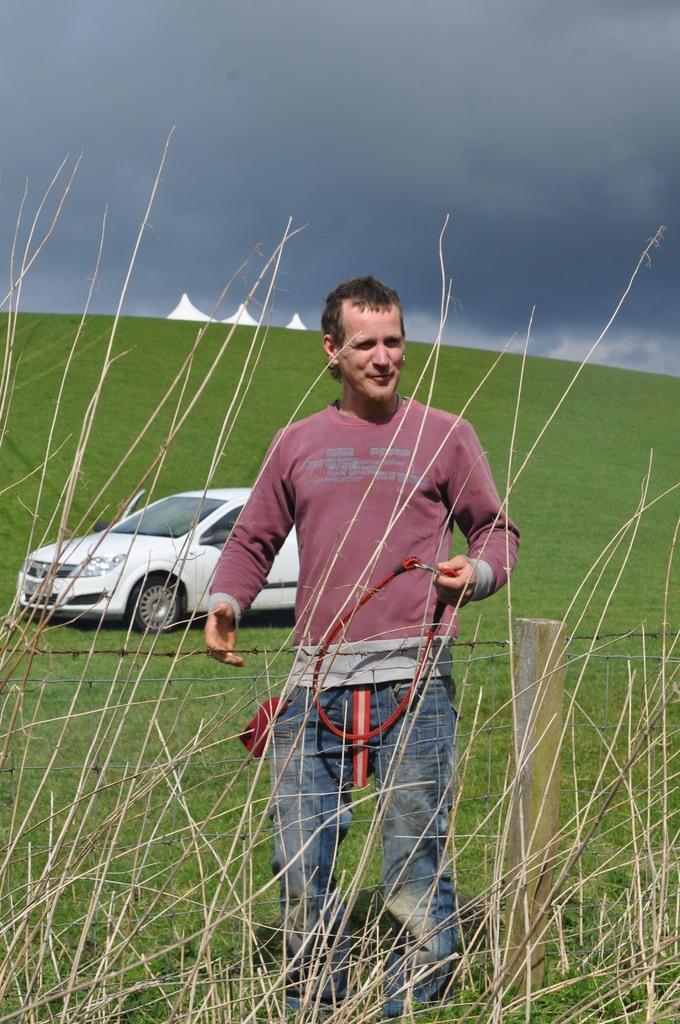Please provide a concise description of this image. In this picture I can see a man standing and he is holding a string in his hand and I can see a car and grass on the ground and I can see metal wire fence and a blue sky. 